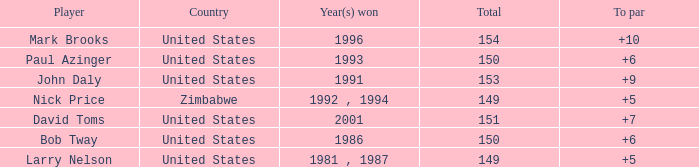Which player won in 1993? Paul Azinger. Could you help me parse every detail presented in this table? {'header': ['Player', 'Country', 'Year(s) won', 'Total', 'To par'], 'rows': [['Mark Brooks', 'United States', '1996', '154', '+10'], ['Paul Azinger', 'United States', '1993', '150', '+6'], ['John Daly', 'United States', '1991', '153', '+9'], ['Nick Price', 'Zimbabwe', '1992 , 1994', '149', '+5'], ['David Toms', 'United States', '2001', '151', '+7'], ['Bob Tway', 'United States', '1986', '150', '+6'], ['Larry Nelson', 'United States', '1981 , 1987', '149', '+5']]} 